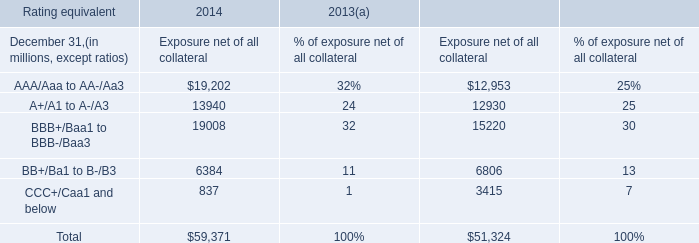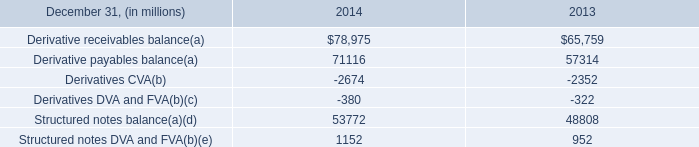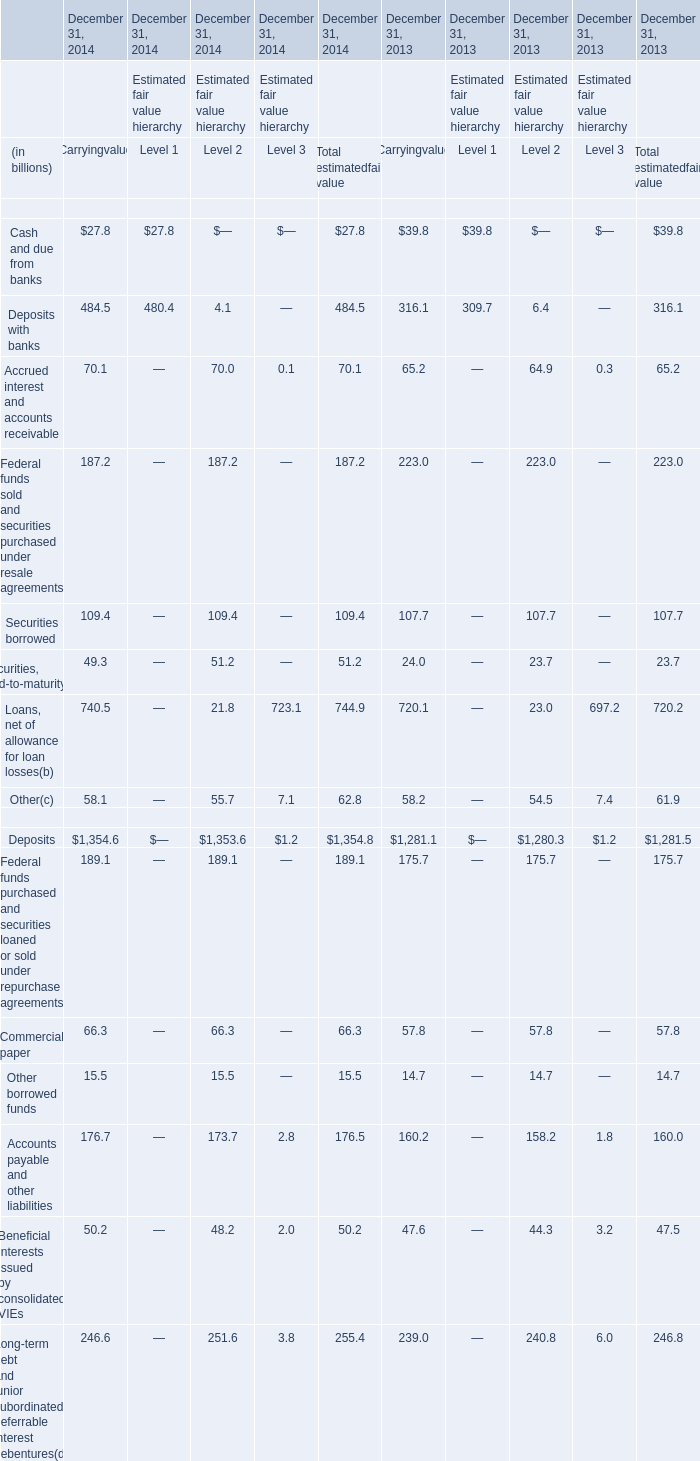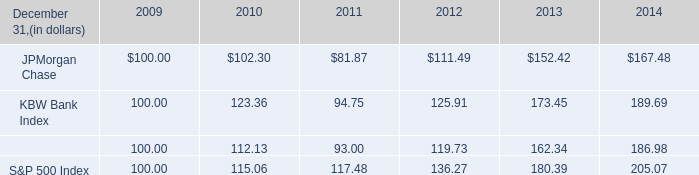at december 31 , 2014 what was the structured notes fva balance in billions? 
Computations: ((1152 / 1000) - 1.4)
Answer: -0.248. 